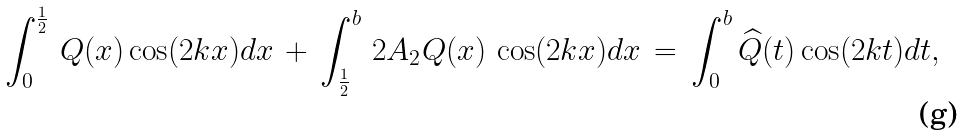Convert formula to latex. <formula><loc_0><loc_0><loc_500><loc_500>\int _ { 0 } ^ { \frac { 1 } { 2 } } \, Q ( x ) \cos ( 2 k x ) d x \, + \, \int _ { \frac { 1 } { 2 } } ^ { b } \, 2 A _ { 2 } Q ( x ) \, \cos ( 2 k x ) d x \, = \, \int _ { 0 } ^ { b } \widehat { Q } ( t ) \cos ( 2 k t ) d t ,</formula> 